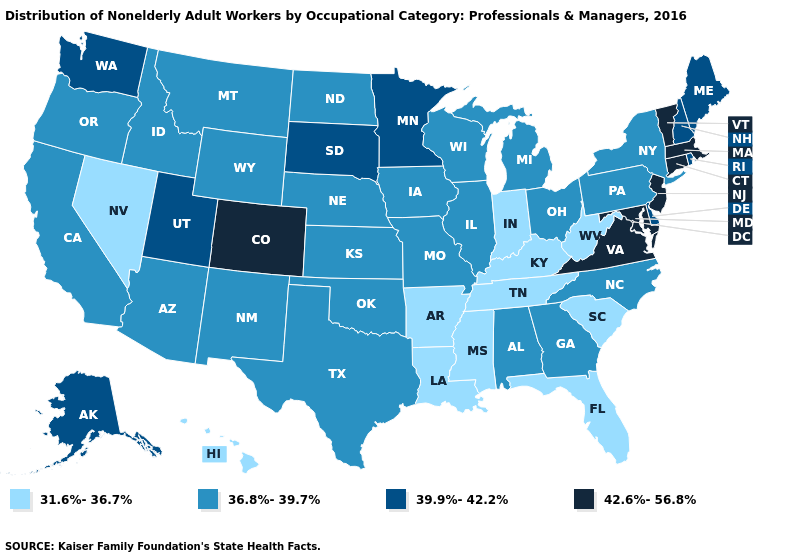Does Alabama have a lower value than Oregon?
Quick response, please. No. Does Virginia have the same value as Mississippi?
Keep it brief. No. What is the value of Vermont?
Keep it brief. 42.6%-56.8%. What is the lowest value in states that border Washington?
Answer briefly. 36.8%-39.7%. Among the states that border Kentucky , which have the lowest value?
Be succinct. Indiana, Tennessee, West Virginia. What is the value of West Virginia?
Short answer required. 31.6%-36.7%. Among the states that border Massachusetts , which have the lowest value?
Answer briefly. New York. Does the map have missing data?
Write a very short answer. No. Does Indiana have the lowest value in the MidWest?
Keep it brief. Yes. What is the value of North Dakota?
Write a very short answer. 36.8%-39.7%. Among the states that border Iowa , which have the highest value?
Give a very brief answer. Minnesota, South Dakota. Does the first symbol in the legend represent the smallest category?
Answer briefly. Yes. Does Michigan have a lower value than California?
Quick response, please. No. What is the value of Maine?
Keep it brief. 39.9%-42.2%. Does New York have the highest value in the USA?
Write a very short answer. No. 